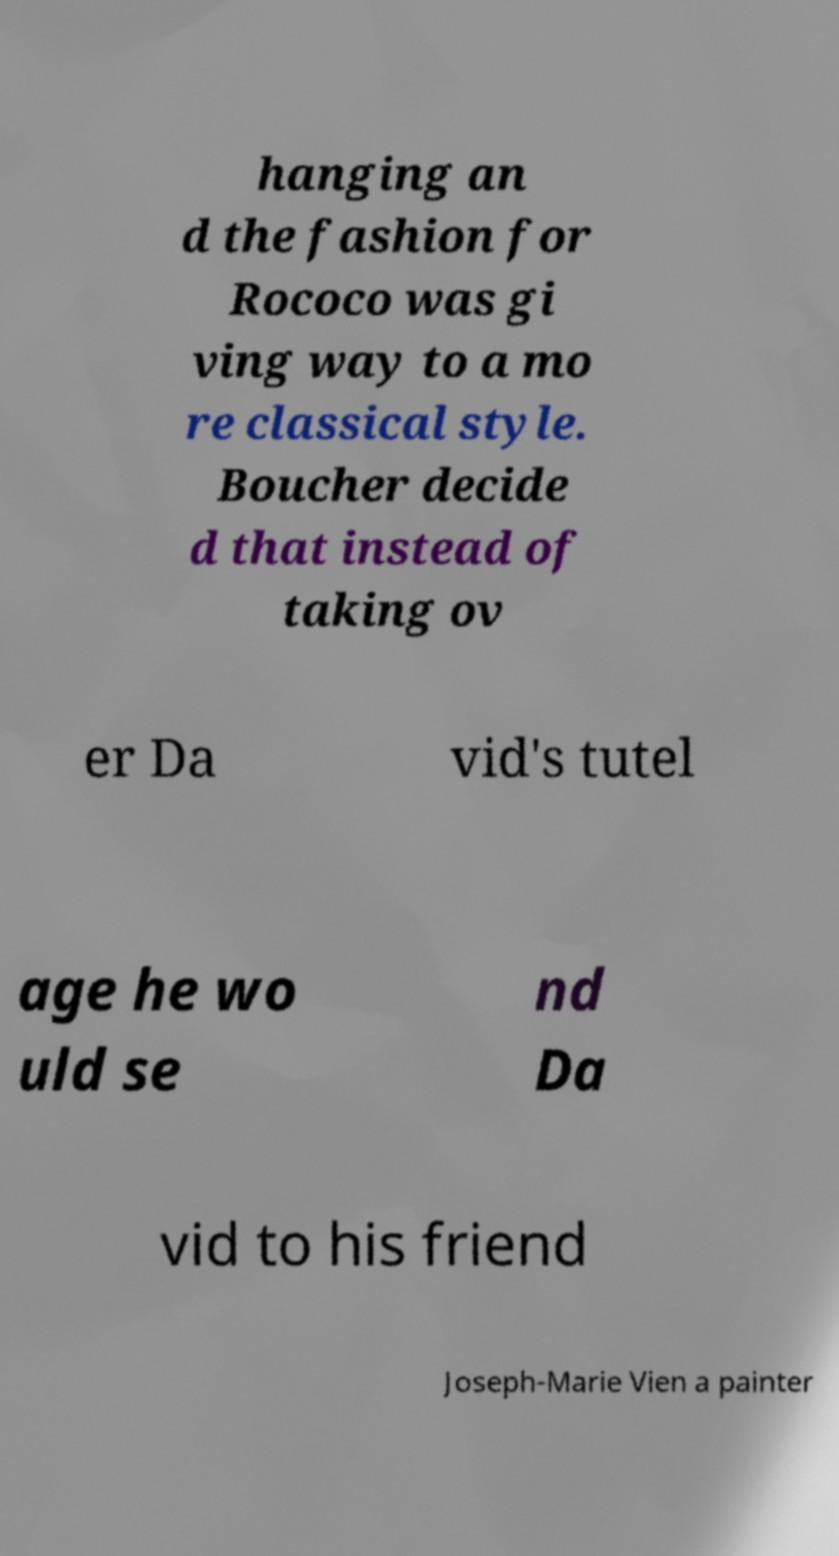I need the written content from this picture converted into text. Can you do that? hanging an d the fashion for Rococo was gi ving way to a mo re classical style. Boucher decide d that instead of taking ov er Da vid's tutel age he wo uld se nd Da vid to his friend Joseph-Marie Vien a painter 